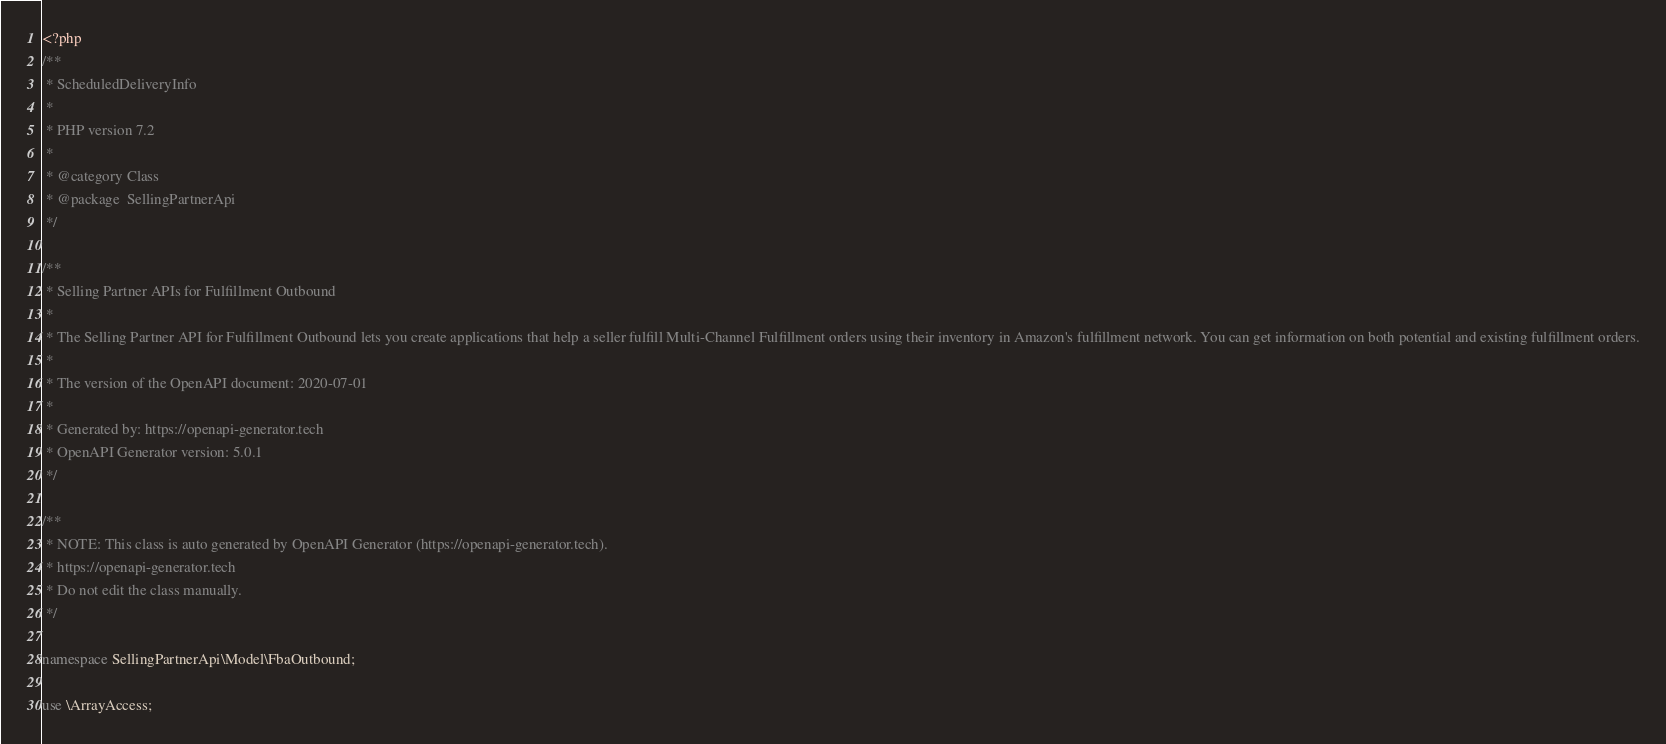<code> <loc_0><loc_0><loc_500><loc_500><_PHP_><?php
/**
 * ScheduledDeliveryInfo
 *
 * PHP version 7.2
 *
 * @category Class
 * @package  SellingPartnerApi
 */

/**
 * Selling Partner APIs for Fulfillment Outbound
 *
 * The Selling Partner API for Fulfillment Outbound lets you create applications that help a seller fulfill Multi-Channel Fulfillment orders using their inventory in Amazon's fulfillment network. You can get information on both potential and existing fulfillment orders.
 *
 * The version of the OpenAPI document: 2020-07-01
 * 
 * Generated by: https://openapi-generator.tech
 * OpenAPI Generator version: 5.0.1
 */

/**
 * NOTE: This class is auto generated by OpenAPI Generator (https://openapi-generator.tech).
 * https://openapi-generator.tech
 * Do not edit the class manually.
 */

namespace SellingPartnerApi\Model\FbaOutbound;

use \ArrayAccess;</code> 